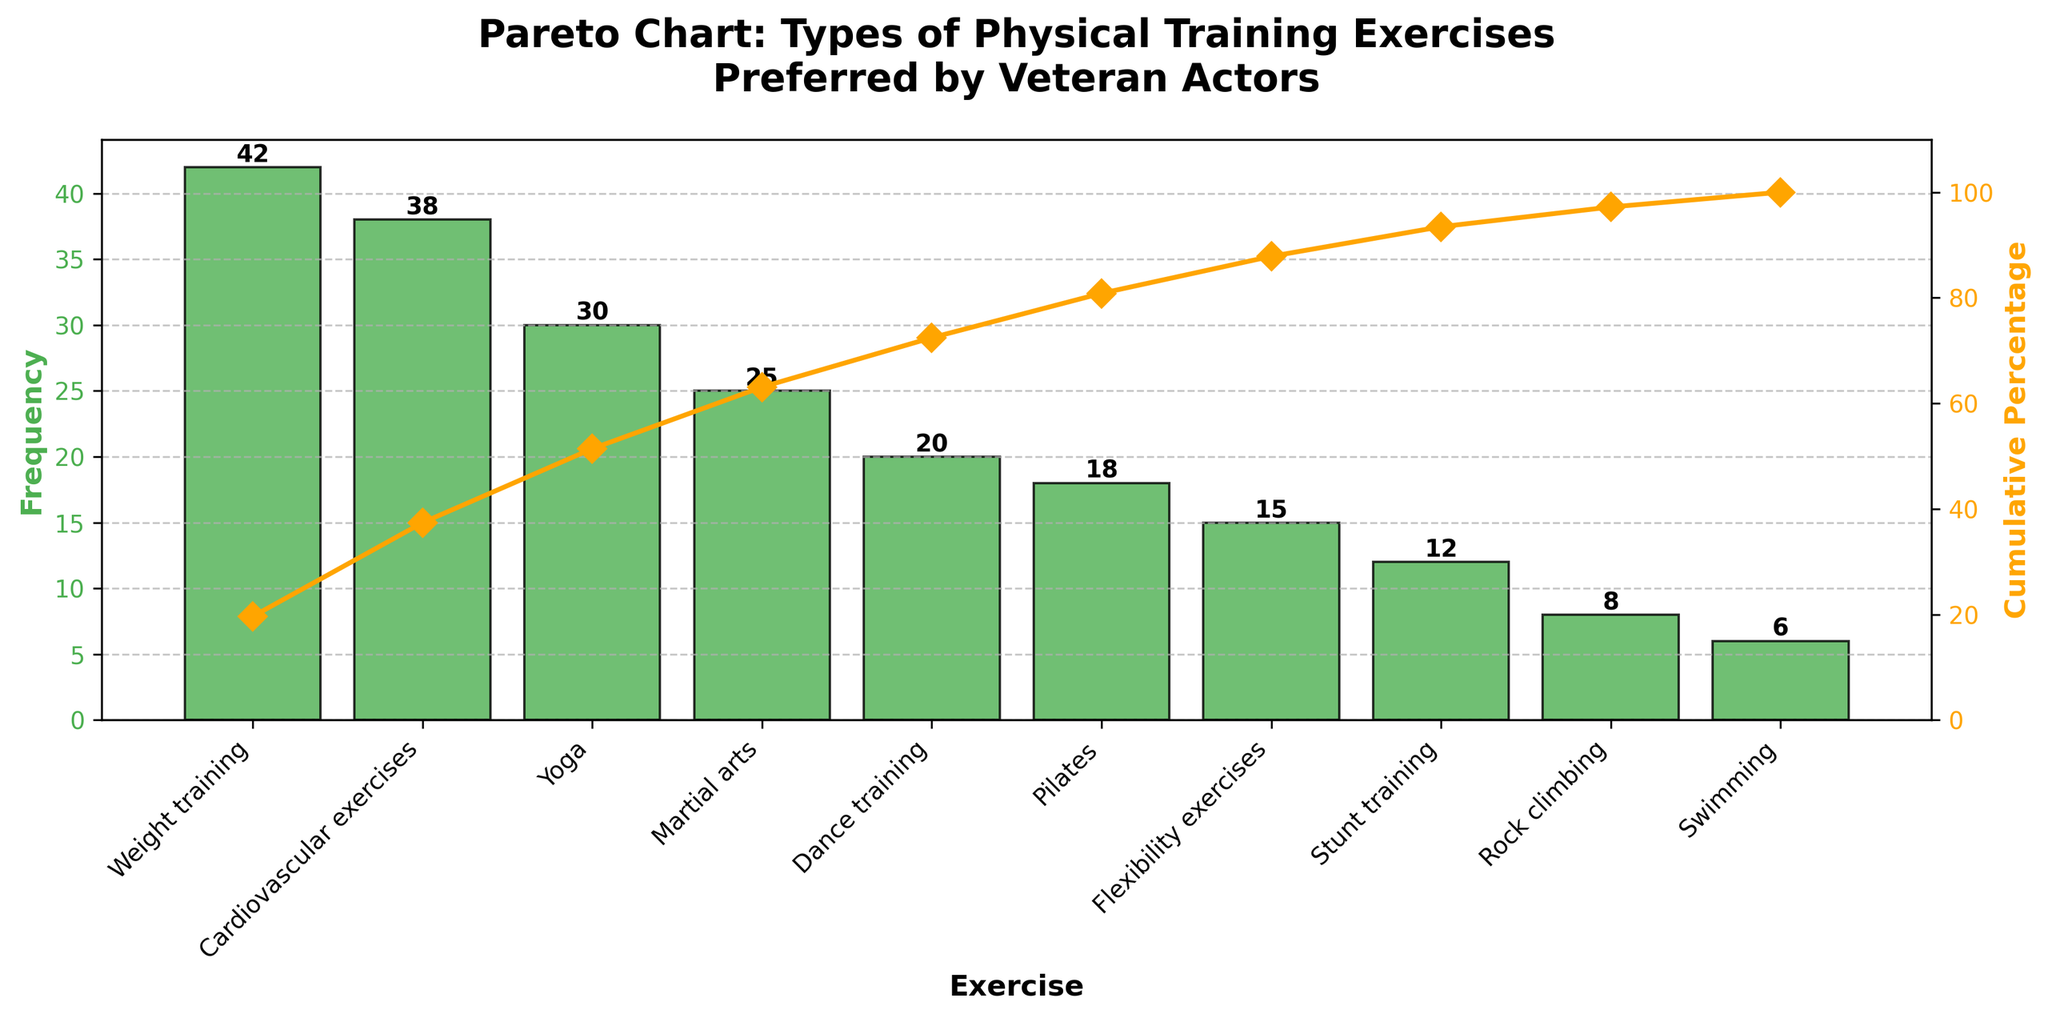What is the most preferred type of physical training exercise by veteran actors? The bar with the highest value represents the most preferred type of exercise.
Answer: Weight training How many veteran actors prefer Pilates? Look for the bar labeled "Pilates" and read its height.
Answer: 18 What percentage of cumulative frequency is reached by the third exercise? Locate the cumulative percentage line at the third exercise (Yoga) and read the value from the right y-axis.
Answer: Approximately 63% Which type of exercise is preferred more, Martial arts or Dance training? Compare the heights of the bars labeled "Martial arts" and "Dance training."
Answer: Martial arts What is the title of the figure? The title is displayed at the top of the figure.
Answer: Pareto Chart: Types of Physical Training Exercises Preferred by Veteran Actors What is the cumulative percentage after Weight training, Cardiovascular exercises, and Yoga? Add the cumulative percentages of these three bars: 29%, 52%, and 63%.
Answer: Approximately 63% How many types of physical training exercises have a frequency of 20 or more? Count all bars with a height of 20 or more.
Answer: 5 Which exercise has the lowest frequency among the veteran actors? Identify the bar with the lowest height.
Answer: Swimming By how much does the number of actors preferring Weight training exceed those preferring Swimming? Subtract the frequency of Swimming from Weight training: 42 - 6 = 36
Answer: 36 What is the dominant color of the bars representing the frequency of exercises? Identify the color of the bars.
Answer: Green 